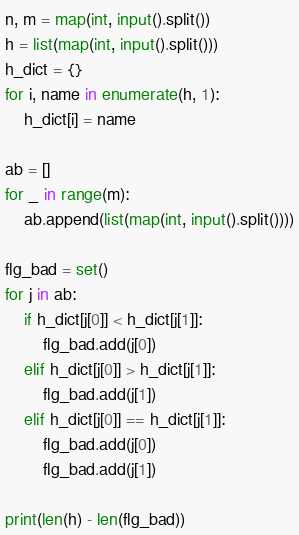Convert code to text. <code><loc_0><loc_0><loc_500><loc_500><_Python_>n, m = map(int, input().split())
h = list(map(int, input().split()))
h_dict = {}
for i, name in enumerate(h, 1):
    h_dict[i] = name

ab = []
for _ in range(m):
    ab.append(list(map(int, input().split())))

flg_bad = set()
for j in ab:
    if h_dict[j[0]] < h_dict[j[1]]:
        flg_bad.add(j[0])
    elif h_dict[j[0]] > h_dict[j[1]]:
        flg_bad.add(j[1])
    elif h_dict[j[0]] == h_dict[j[1]]:
        flg_bad.add(j[0])
        flg_bad.add(j[1])

print(len(h) - len(flg_bad))</code> 